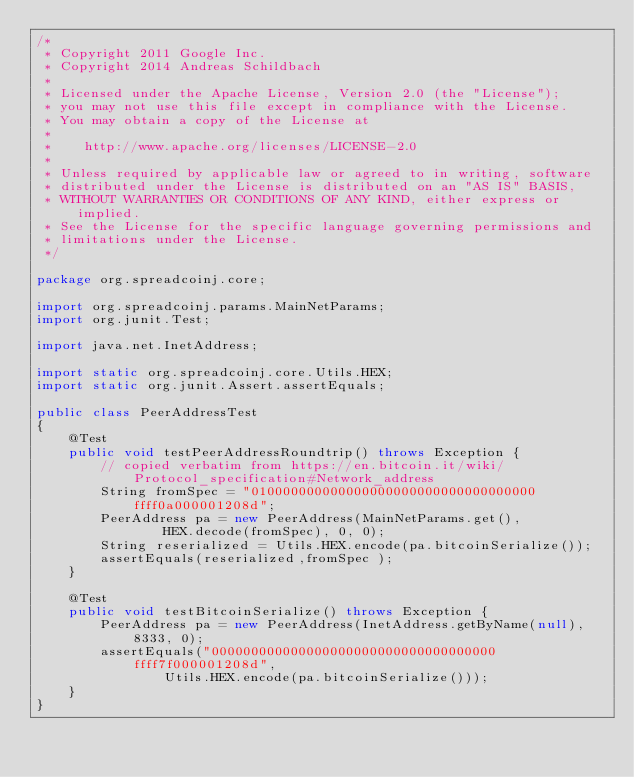Convert code to text. <code><loc_0><loc_0><loc_500><loc_500><_Java_>/*
 * Copyright 2011 Google Inc.
 * Copyright 2014 Andreas Schildbach
 *
 * Licensed under the Apache License, Version 2.0 (the "License");
 * you may not use this file except in compliance with the License.
 * You may obtain a copy of the License at
 *
 *    http://www.apache.org/licenses/LICENSE-2.0
 *
 * Unless required by applicable law or agreed to in writing, software
 * distributed under the License is distributed on an "AS IS" BASIS,
 * WITHOUT WARRANTIES OR CONDITIONS OF ANY KIND, either express or implied.
 * See the License for the specific language governing permissions and
 * limitations under the License.
 */

package org.spreadcoinj.core;

import org.spreadcoinj.params.MainNetParams;
import org.junit.Test;

import java.net.InetAddress;

import static org.spreadcoinj.core.Utils.HEX;
import static org.junit.Assert.assertEquals;

public class PeerAddressTest
{
    @Test
    public void testPeerAddressRoundtrip() throws Exception {
        // copied verbatim from https://en.bitcoin.it/wiki/Protocol_specification#Network_address
        String fromSpec = "010000000000000000000000000000000000ffff0a000001208d";
        PeerAddress pa = new PeerAddress(MainNetParams.get(),
                HEX.decode(fromSpec), 0, 0);
        String reserialized = Utils.HEX.encode(pa.bitcoinSerialize());
        assertEquals(reserialized,fromSpec );
    }

    @Test
    public void testBitcoinSerialize() throws Exception {
        PeerAddress pa = new PeerAddress(InetAddress.getByName(null), 8333, 0);
        assertEquals("000000000000000000000000000000000000ffff7f000001208d",
                Utils.HEX.encode(pa.bitcoinSerialize()));
    }
}
</code> 